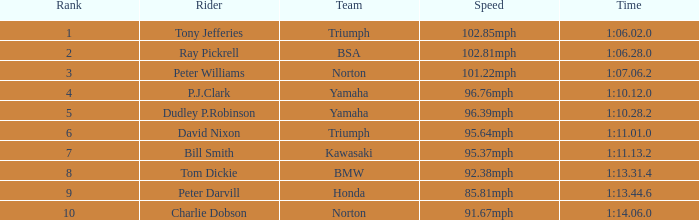0 timing? Tony Jefferies. 